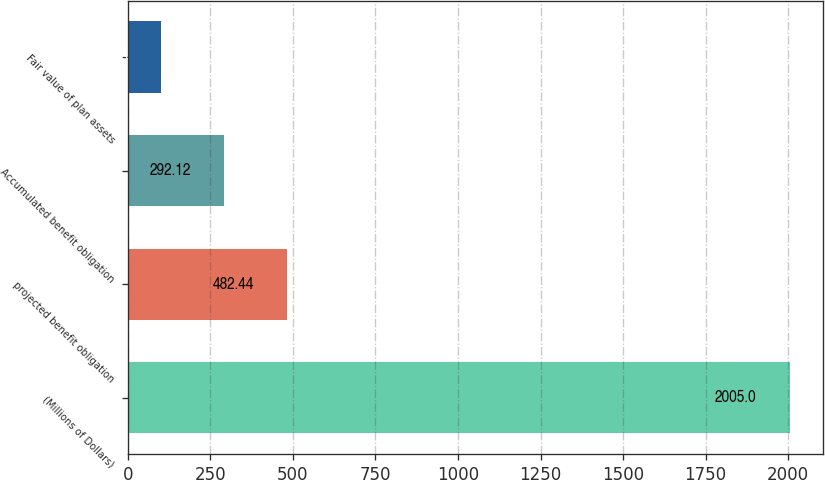Convert chart. <chart><loc_0><loc_0><loc_500><loc_500><bar_chart><fcel>(Millions of Dollars)<fcel>projected benefit obligation<fcel>Accumulated benefit obligation<fcel>Fair value of plan assets<nl><fcel>2005<fcel>482.44<fcel>292.12<fcel>101.8<nl></chart> 